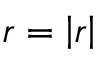Convert formula to latex. <formula><loc_0><loc_0><loc_500><loc_500>r = \left | r \right |</formula> 